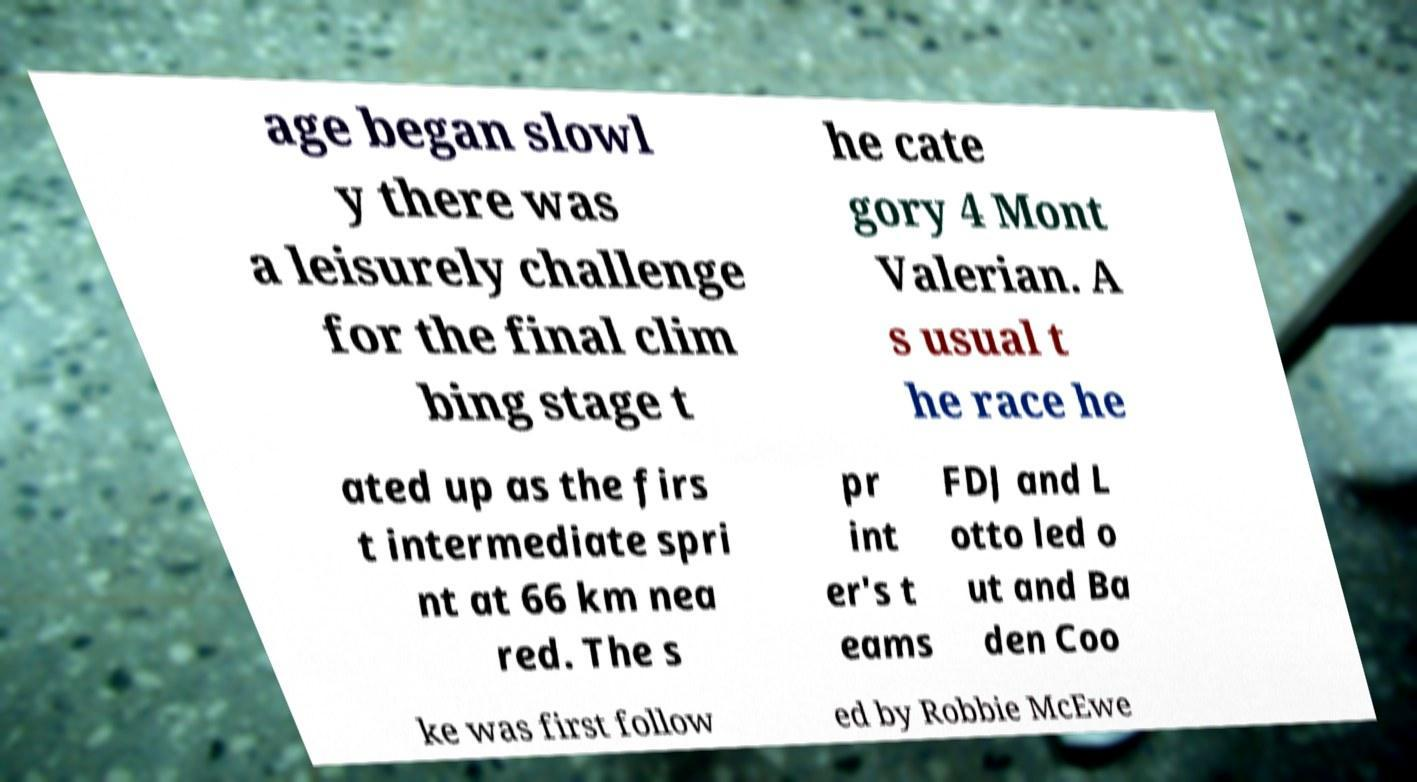There's text embedded in this image that I need extracted. Can you transcribe it verbatim? age began slowl y there was a leisurely challenge for the final clim bing stage t he cate gory 4 Mont Valerian. A s usual t he race he ated up as the firs t intermediate spri nt at 66 km nea red. The s pr int er's t eams FDJ and L otto led o ut and Ba den Coo ke was first follow ed by Robbie McEwe 